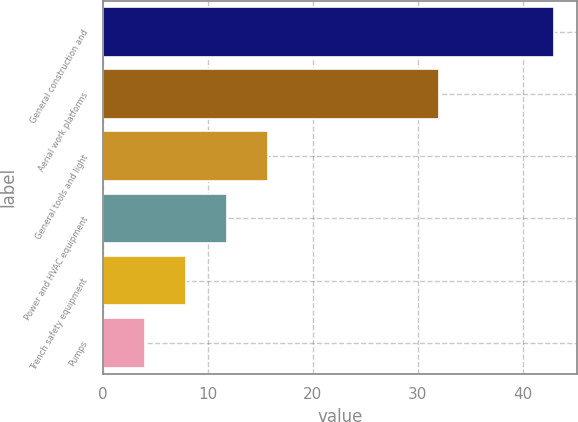<chart> <loc_0><loc_0><loc_500><loc_500><bar_chart><fcel>General construction and<fcel>Aerial work platforms<fcel>General tools and light<fcel>Power and HVAC equipment<fcel>Trench safety equipment<fcel>Pumps<nl><fcel>43<fcel>32<fcel>15.7<fcel>11.8<fcel>7.9<fcel>4<nl></chart> 